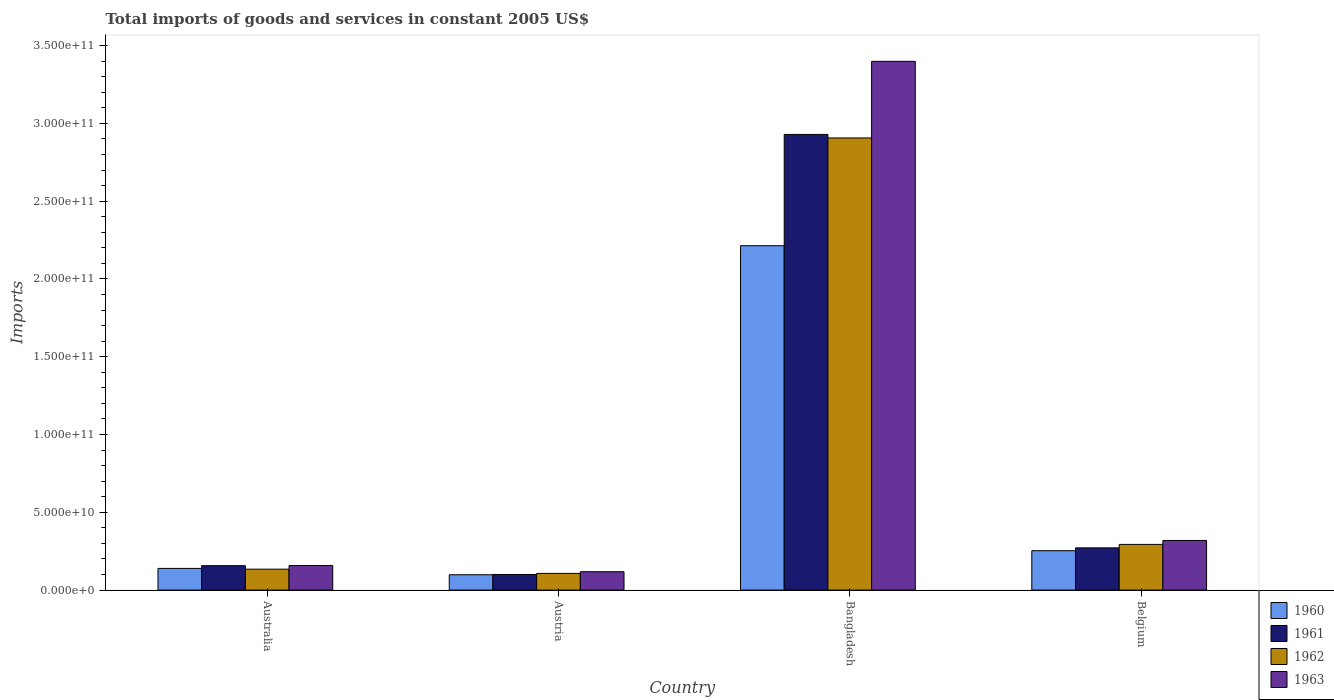How many groups of bars are there?
Your answer should be compact. 4. Are the number of bars per tick equal to the number of legend labels?
Your answer should be very brief. Yes. What is the label of the 3rd group of bars from the left?
Offer a very short reply. Bangladesh. In how many cases, is the number of bars for a given country not equal to the number of legend labels?
Provide a succinct answer. 0. What is the total imports of goods and services in 1963 in Australia?
Your answer should be very brief. 1.58e+1. Across all countries, what is the maximum total imports of goods and services in 1962?
Ensure brevity in your answer.  2.91e+11. Across all countries, what is the minimum total imports of goods and services in 1962?
Make the answer very short. 1.07e+1. In which country was the total imports of goods and services in 1961 maximum?
Ensure brevity in your answer.  Bangladesh. In which country was the total imports of goods and services in 1962 minimum?
Keep it short and to the point. Austria. What is the total total imports of goods and services in 1963 in the graph?
Offer a terse response. 3.99e+11. What is the difference between the total imports of goods and services in 1960 in Austria and that in Bangladesh?
Provide a succinct answer. -2.12e+11. What is the difference between the total imports of goods and services in 1960 in Australia and the total imports of goods and services in 1962 in Bangladesh?
Ensure brevity in your answer.  -2.77e+11. What is the average total imports of goods and services in 1960 per country?
Offer a terse response. 6.76e+1. What is the difference between the total imports of goods and services of/in 1962 and total imports of goods and services of/in 1960 in Bangladesh?
Make the answer very short. 6.93e+1. In how many countries, is the total imports of goods and services in 1962 greater than 190000000000 US$?
Ensure brevity in your answer.  1. What is the ratio of the total imports of goods and services in 1962 in Austria to that in Belgium?
Your response must be concise. 0.37. What is the difference between the highest and the second highest total imports of goods and services in 1961?
Keep it short and to the point. 2.77e+11. What is the difference between the highest and the lowest total imports of goods and services in 1960?
Your response must be concise. 2.12e+11. What does the 4th bar from the left in Austria represents?
Ensure brevity in your answer.  1963. What does the 2nd bar from the right in Bangladesh represents?
Keep it short and to the point. 1962. Are all the bars in the graph horizontal?
Your answer should be compact. No. How many countries are there in the graph?
Your response must be concise. 4. What is the difference between two consecutive major ticks on the Y-axis?
Provide a succinct answer. 5.00e+1. Does the graph contain grids?
Your answer should be compact. No. Where does the legend appear in the graph?
Keep it short and to the point. Bottom right. How many legend labels are there?
Your answer should be very brief. 4. What is the title of the graph?
Your answer should be compact. Total imports of goods and services in constant 2005 US$. Does "1965" appear as one of the legend labels in the graph?
Offer a terse response. No. What is the label or title of the X-axis?
Provide a short and direct response. Country. What is the label or title of the Y-axis?
Make the answer very short. Imports. What is the Imports of 1960 in Australia?
Ensure brevity in your answer.  1.40e+1. What is the Imports in 1961 in Australia?
Provide a succinct answer. 1.57e+1. What is the Imports in 1962 in Australia?
Provide a succinct answer. 1.35e+1. What is the Imports in 1963 in Australia?
Your answer should be compact. 1.58e+1. What is the Imports in 1960 in Austria?
Keep it short and to the point. 9.86e+09. What is the Imports in 1961 in Austria?
Give a very brief answer. 1.00e+1. What is the Imports in 1962 in Austria?
Offer a terse response. 1.07e+1. What is the Imports in 1963 in Austria?
Provide a short and direct response. 1.18e+1. What is the Imports in 1960 in Bangladesh?
Offer a terse response. 2.21e+11. What is the Imports of 1961 in Bangladesh?
Offer a terse response. 2.93e+11. What is the Imports of 1962 in Bangladesh?
Keep it short and to the point. 2.91e+11. What is the Imports in 1963 in Bangladesh?
Give a very brief answer. 3.40e+11. What is the Imports in 1960 in Belgium?
Make the answer very short. 2.53e+1. What is the Imports in 1961 in Belgium?
Your answer should be very brief. 2.72e+1. What is the Imports in 1962 in Belgium?
Provide a short and direct response. 2.94e+1. What is the Imports of 1963 in Belgium?
Your answer should be compact. 3.19e+1. Across all countries, what is the maximum Imports of 1960?
Offer a very short reply. 2.21e+11. Across all countries, what is the maximum Imports in 1961?
Provide a short and direct response. 2.93e+11. Across all countries, what is the maximum Imports in 1962?
Offer a very short reply. 2.91e+11. Across all countries, what is the maximum Imports of 1963?
Your answer should be compact. 3.40e+11. Across all countries, what is the minimum Imports in 1960?
Ensure brevity in your answer.  9.86e+09. Across all countries, what is the minimum Imports in 1961?
Offer a terse response. 1.00e+1. Across all countries, what is the minimum Imports of 1962?
Your answer should be very brief. 1.07e+1. Across all countries, what is the minimum Imports of 1963?
Offer a terse response. 1.18e+1. What is the total Imports of 1960 in the graph?
Your response must be concise. 2.71e+11. What is the total Imports of 1961 in the graph?
Offer a terse response. 3.46e+11. What is the total Imports in 1962 in the graph?
Your answer should be very brief. 3.44e+11. What is the total Imports of 1963 in the graph?
Provide a succinct answer. 3.99e+11. What is the difference between the Imports of 1960 in Australia and that in Austria?
Your answer should be very brief. 4.09e+09. What is the difference between the Imports in 1961 in Australia and that in Austria?
Provide a short and direct response. 5.65e+09. What is the difference between the Imports in 1962 in Australia and that in Austria?
Offer a terse response. 2.73e+09. What is the difference between the Imports in 1963 in Australia and that in Austria?
Offer a very short reply. 3.96e+09. What is the difference between the Imports of 1960 in Australia and that in Bangladesh?
Ensure brevity in your answer.  -2.07e+11. What is the difference between the Imports of 1961 in Australia and that in Bangladesh?
Offer a terse response. -2.77e+11. What is the difference between the Imports of 1962 in Australia and that in Bangladesh?
Your answer should be very brief. -2.77e+11. What is the difference between the Imports of 1963 in Australia and that in Bangladesh?
Your answer should be compact. -3.24e+11. What is the difference between the Imports of 1960 in Australia and that in Belgium?
Ensure brevity in your answer.  -1.14e+1. What is the difference between the Imports of 1961 in Australia and that in Belgium?
Your answer should be very brief. -1.15e+1. What is the difference between the Imports of 1962 in Australia and that in Belgium?
Provide a short and direct response. -1.59e+1. What is the difference between the Imports of 1963 in Australia and that in Belgium?
Make the answer very short. -1.61e+1. What is the difference between the Imports of 1960 in Austria and that in Bangladesh?
Your answer should be very brief. -2.12e+11. What is the difference between the Imports in 1961 in Austria and that in Bangladesh?
Provide a short and direct response. -2.83e+11. What is the difference between the Imports in 1962 in Austria and that in Bangladesh?
Your answer should be very brief. -2.80e+11. What is the difference between the Imports of 1963 in Austria and that in Bangladesh?
Your answer should be compact. -3.28e+11. What is the difference between the Imports in 1960 in Austria and that in Belgium?
Keep it short and to the point. -1.55e+1. What is the difference between the Imports in 1961 in Austria and that in Belgium?
Ensure brevity in your answer.  -1.71e+1. What is the difference between the Imports in 1962 in Austria and that in Belgium?
Your answer should be compact. -1.87e+1. What is the difference between the Imports in 1963 in Austria and that in Belgium?
Your answer should be compact. -2.01e+1. What is the difference between the Imports of 1960 in Bangladesh and that in Belgium?
Provide a short and direct response. 1.96e+11. What is the difference between the Imports in 1961 in Bangladesh and that in Belgium?
Your response must be concise. 2.66e+11. What is the difference between the Imports of 1962 in Bangladesh and that in Belgium?
Keep it short and to the point. 2.61e+11. What is the difference between the Imports of 1963 in Bangladesh and that in Belgium?
Offer a terse response. 3.08e+11. What is the difference between the Imports in 1960 in Australia and the Imports in 1961 in Austria?
Give a very brief answer. 3.91e+09. What is the difference between the Imports of 1960 in Australia and the Imports of 1962 in Austria?
Provide a short and direct response. 3.22e+09. What is the difference between the Imports in 1960 in Australia and the Imports in 1963 in Austria?
Give a very brief answer. 2.12e+09. What is the difference between the Imports in 1961 in Australia and the Imports in 1962 in Austria?
Your answer should be compact. 4.97e+09. What is the difference between the Imports of 1961 in Australia and the Imports of 1963 in Austria?
Make the answer very short. 3.87e+09. What is the difference between the Imports of 1962 in Australia and the Imports of 1963 in Austria?
Give a very brief answer. 1.63e+09. What is the difference between the Imports in 1960 in Australia and the Imports in 1961 in Bangladesh?
Your response must be concise. -2.79e+11. What is the difference between the Imports in 1960 in Australia and the Imports in 1962 in Bangladesh?
Keep it short and to the point. -2.77e+11. What is the difference between the Imports in 1960 in Australia and the Imports in 1963 in Bangladesh?
Offer a very short reply. -3.26e+11. What is the difference between the Imports of 1961 in Australia and the Imports of 1962 in Bangladesh?
Your answer should be very brief. -2.75e+11. What is the difference between the Imports of 1961 in Australia and the Imports of 1963 in Bangladesh?
Your answer should be very brief. -3.24e+11. What is the difference between the Imports of 1962 in Australia and the Imports of 1963 in Bangladesh?
Keep it short and to the point. -3.26e+11. What is the difference between the Imports in 1960 in Australia and the Imports in 1961 in Belgium?
Provide a short and direct response. -1.32e+1. What is the difference between the Imports of 1960 in Australia and the Imports of 1962 in Belgium?
Make the answer very short. -1.54e+1. What is the difference between the Imports of 1960 in Australia and the Imports of 1963 in Belgium?
Give a very brief answer. -1.80e+1. What is the difference between the Imports of 1961 in Australia and the Imports of 1962 in Belgium?
Offer a terse response. -1.37e+1. What is the difference between the Imports in 1961 in Australia and the Imports in 1963 in Belgium?
Provide a short and direct response. -1.62e+1. What is the difference between the Imports of 1962 in Australia and the Imports of 1963 in Belgium?
Offer a terse response. -1.85e+1. What is the difference between the Imports in 1960 in Austria and the Imports in 1961 in Bangladesh?
Provide a succinct answer. -2.83e+11. What is the difference between the Imports of 1960 in Austria and the Imports of 1962 in Bangladesh?
Provide a succinct answer. -2.81e+11. What is the difference between the Imports of 1960 in Austria and the Imports of 1963 in Bangladesh?
Keep it short and to the point. -3.30e+11. What is the difference between the Imports in 1961 in Austria and the Imports in 1962 in Bangladesh?
Provide a succinct answer. -2.81e+11. What is the difference between the Imports in 1961 in Austria and the Imports in 1963 in Bangladesh?
Offer a terse response. -3.30e+11. What is the difference between the Imports of 1962 in Austria and the Imports of 1963 in Bangladesh?
Keep it short and to the point. -3.29e+11. What is the difference between the Imports of 1960 in Austria and the Imports of 1961 in Belgium?
Keep it short and to the point. -1.73e+1. What is the difference between the Imports of 1960 in Austria and the Imports of 1962 in Belgium?
Your response must be concise. -1.95e+1. What is the difference between the Imports of 1960 in Austria and the Imports of 1963 in Belgium?
Provide a short and direct response. -2.21e+1. What is the difference between the Imports of 1961 in Austria and the Imports of 1962 in Belgium?
Keep it short and to the point. -1.93e+1. What is the difference between the Imports of 1961 in Austria and the Imports of 1963 in Belgium?
Your answer should be compact. -2.19e+1. What is the difference between the Imports of 1962 in Austria and the Imports of 1963 in Belgium?
Provide a succinct answer. -2.12e+1. What is the difference between the Imports in 1960 in Bangladesh and the Imports in 1961 in Belgium?
Provide a short and direct response. 1.94e+11. What is the difference between the Imports of 1960 in Bangladesh and the Imports of 1962 in Belgium?
Your answer should be compact. 1.92e+11. What is the difference between the Imports of 1960 in Bangladesh and the Imports of 1963 in Belgium?
Your response must be concise. 1.89e+11. What is the difference between the Imports of 1961 in Bangladesh and the Imports of 1962 in Belgium?
Provide a succinct answer. 2.64e+11. What is the difference between the Imports of 1961 in Bangladesh and the Imports of 1963 in Belgium?
Your response must be concise. 2.61e+11. What is the difference between the Imports of 1962 in Bangladesh and the Imports of 1963 in Belgium?
Your answer should be compact. 2.59e+11. What is the average Imports of 1960 per country?
Your answer should be compact. 6.76e+1. What is the average Imports in 1961 per country?
Your response must be concise. 8.65e+1. What is the average Imports of 1962 per country?
Offer a terse response. 8.61e+1. What is the average Imports of 1963 per country?
Offer a terse response. 9.99e+1. What is the difference between the Imports in 1960 and Imports in 1961 in Australia?
Provide a succinct answer. -1.75e+09. What is the difference between the Imports in 1960 and Imports in 1962 in Australia?
Offer a terse response. 4.92e+08. What is the difference between the Imports of 1960 and Imports of 1963 in Australia?
Offer a very short reply. -1.84e+09. What is the difference between the Imports in 1961 and Imports in 1962 in Australia?
Your answer should be very brief. 2.24e+09. What is the difference between the Imports of 1961 and Imports of 1963 in Australia?
Ensure brevity in your answer.  -9.40e+07. What is the difference between the Imports of 1962 and Imports of 1963 in Australia?
Provide a succinct answer. -2.33e+09. What is the difference between the Imports of 1960 and Imports of 1961 in Austria?
Ensure brevity in your answer.  -1.83e+08. What is the difference between the Imports of 1960 and Imports of 1962 in Austria?
Offer a terse response. -8.69e+08. What is the difference between the Imports of 1960 and Imports of 1963 in Austria?
Provide a short and direct response. -1.97e+09. What is the difference between the Imports in 1961 and Imports in 1962 in Austria?
Your answer should be compact. -6.86e+08. What is the difference between the Imports in 1961 and Imports in 1963 in Austria?
Offer a terse response. -1.78e+09. What is the difference between the Imports of 1962 and Imports of 1963 in Austria?
Your response must be concise. -1.10e+09. What is the difference between the Imports in 1960 and Imports in 1961 in Bangladesh?
Your answer should be very brief. -7.15e+1. What is the difference between the Imports of 1960 and Imports of 1962 in Bangladesh?
Your answer should be compact. -6.93e+1. What is the difference between the Imports of 1960 and Imports of 1963 in Bangladesh?
Keep it short and to the point. -1.19e+11. What is the difference between the Imports in 1961 and Imports in 1962 in Bangladesh?
Offer a very short reply. 2.26e+09. What is the difference between the Imports in 1961 and Imports in 1963 in Bangladesh?
Make the answer very short. -4.70e+1. What is the difference between the Imports of 1962 and Imports of 1963 in Bangladesh?
Your answer should be very brief. -4.93e+1. What is the difference between the Imports of 1960 and Imports of 1961 in Belgium?
Provide a short and direct response. -1.82e+09. What is the difference between the Imports in 1960 and Imports in 1962 in Belgium?
Ensure brevity in your answer.  -4.05e+09. What is the difference between the Imports in 1960 and Imports in 1963 in Belgium?
Ensure brevity in your answer.  -6.59e+09. What is the difference between the Imports of 1961 and Imports of 1962 in Belgium?
Offer a terse response. -2.23e+09. What is the difference between the Imports in 1961 and Imports in 1963 in Belgium?
Provide a succinct answer. -4.77e+09. What is the difference between the Imports of 1962 and Imports of 1963 in Belgium?
Provide a short and direct response. -2.54e+09. What is the ratio of the Imports of 1960 in Australia to that in Austria?
Offer a very short reply. 1.41. What is the ratio of the Imports in 1961 in Australia to that in Austria?
Your answer should be very brief. 1.56. What is the ratio of the Imports of 1962 in Australia to that in Austria?
Make the answer very short. 1.25. What is the ratio of the Imports in 1963 in Australia to that in Austria?
Provide a succinct answer. 1.33. What is the ratio of the Imports in 1960 in Australia to that in Bangladesh?
Provide a short and direct response. 0.06. What is the ratio of the Imports of 1961 in Australia to that in Bangladesh?
Keep it short and to the point. 0.05. What is the ratio of the Imports in 1962 in Australia to that in Bangladesh?
Your answer should be compact. 0.05. What is the ratio of the Imports of 1963 in Australia to that in Bangladesh?
Your answer should be very brief. 0.05. What is the ratio of the Imports of 1960 in Australia to that in Belgium?
Make the answer very short. 0.55. What is the ratio of the Imports of 1961 in Australia to that in Belgium?
Offer a terse response. 0.58. What is the ratio of the Imports of 1962 in Australia to that in Belgium?
Your answer should be compact. 0.46. What is the ratio of the Imports in 1963 in Australia to that in Belgium?
Your answer should be compact. 0.49. What is the ratio of the Imports in 1960 in Austria to that in Bangladesh?
Your response must be concise. 0.04. What is the ratio of the Imports of 1961 in Austria to that in Bangladesh?
Offer a terse response. 0.03. What is the ratio of the Imports in 1962 in Austria to that in Bangladesh?
Make the answer very short. 0.04. What is the ratio of the Imports in 1963 in Austria to that in Bangladesh?
Ensure brevity in your answer.  0.03. What is the ratio of the Imports of 1960 in Austria to that in Belgium?
Your answer should be very brief. 0.39. What is the ratio of the Imports of 1961 in Austria to that in Belgium?
Provide a short and direct response. 0.37. What is the ratio of the Imports of 1962 in Austria to that in Belgium?
Provide a short and direct response. 0.37. What is the ratio of the Imports in 1963 in Austria to that in Belgium?
Offer a terse response. 0.37. What is the ratio of the Imports of 1960 in Bangladesh to that in Belgium?
Provide a short and direct response. 8.74. What is the ratio of the Imports of 1961 in Bangladesh to that in Belgium?
Your answer should be compact. 10.79. What is the ratio of the Imports of 1962 in Bangladesh to that in Belgium?
Offer a terse response. 9.89. What is the ratio of the Imports of 1963 in Bangladesh to that in Belgium?
Ensure brevity in your answer.  10.65. What is the difference between the highest and the second highest Imports in 1960?
Provide a short and direct response. 1.96e+11. What is the difference between the highest and the second highest Imports in 1961?
Keep it short and to the point. 2.66e+11. What is the difference between the highest and the second highest Imports of 1962?
Provide a short and direct response. 2.61e+11. What is the difference between the highest and the second highest Imports of 1963?
Offer a very short reply. 3.08e+11. What is the difference between the highest and the lowest Imports of 1960?
Offer a terse response. 2.12e+11. What is the difference between the highest and the lowest Imports in 1961?
Ensure brevity in your answer.  2.83e+11. What is the difference between the highest and the lowest Imports of 1962?
Provide a short and direct response. 2.80e+11. What is the difference between the highest and the lowest Imports in 1963?
Provide a succinct answer. 3.28e+11. 